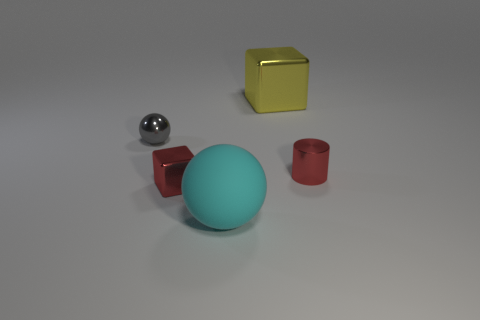Add 3 big cyan matte objects. How many objects exist? 8 Subtract all cylinders. How many objects are left? 4 Subtract all small cubes. Subtract all matte objects. How many objects are left? 3 Add 1 metallic blocks. How many metallic blocks are left? 3 Add 4 cyan balls. How many cyan balls exist? 5 Subtract 0 green balls. How many objects are left? 5 